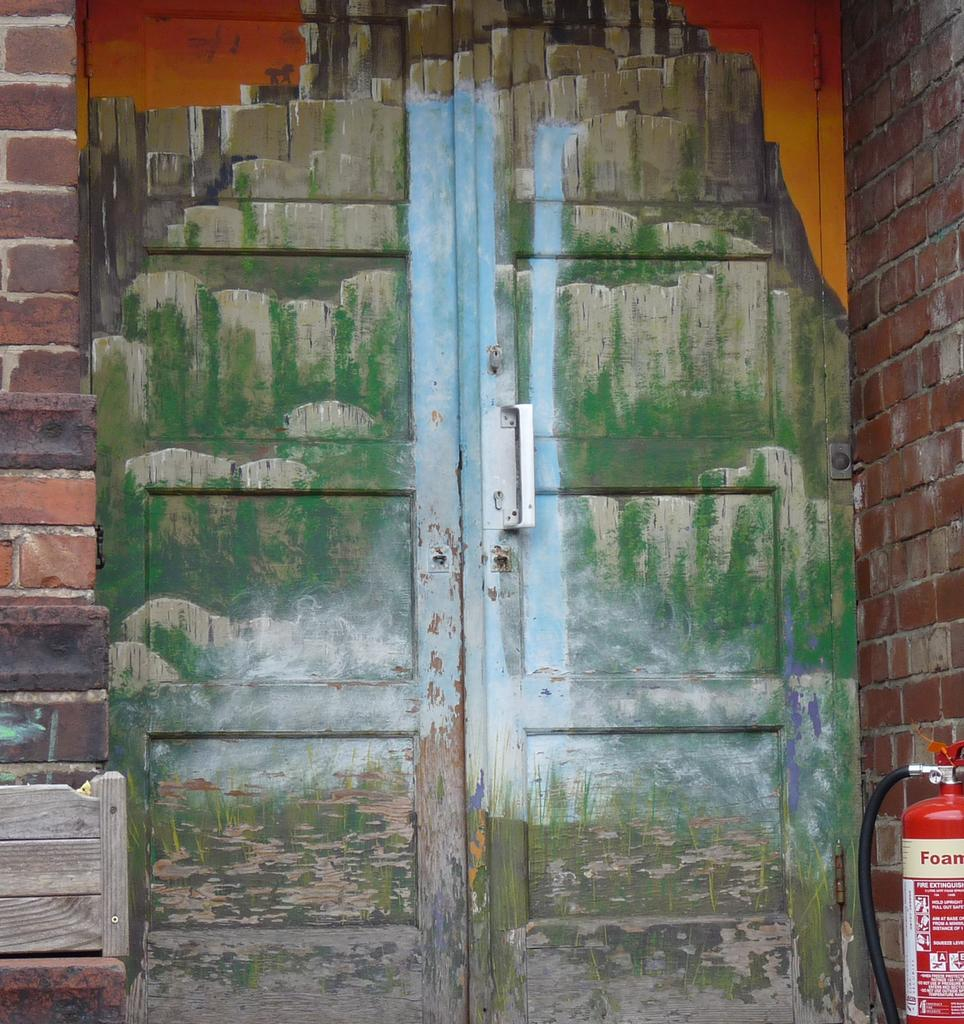What is the main object in the image? There is a door in the image. How is the door connected to the wall? The door is attached to a wall. What decorative elements are on the door? There are paintings on the door. What is located in the bottom right of the image? There is a cylinder in the bottom right of the image. What can be found on the cylinder? There is text on the cylinder. Can you tell me what color sweater your aunt is wearing in the image? There is no person, let alone an aunt, present in the image. 